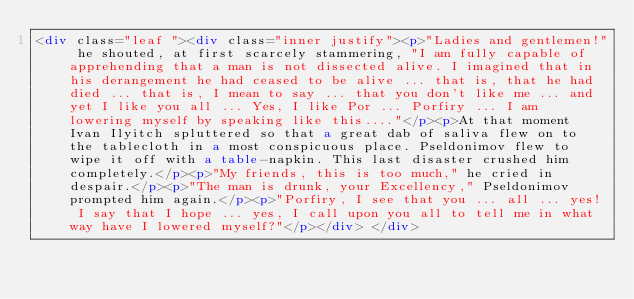Convert code to text. <code><loc_0><loc_0><loc_500><loc_500><_HTML_><div class="leaf "><div class="inner justify"><p>"Ladies and gentlemen!" he shouted, at first scarcely stammering, "I am fully capable of apprehending that a man is not dissected alive. I imagined that in his derangement he had ceased to be alive ... that is, that he had died ... that is, I mean to say ... that you don't like me ... and yet I like you all ... Yes, I like Por ... Porfiry ... I am lowering myself by speaking like this...."</p><p>At that moment Ivan Ilyitch spluttered so that a great dab of saliva flew on to the tablecloth in a most conspicuous place. Pseldonimov flew to wipe it off with a table-napkin. This last disaster crushed him completely.</p><p>"My friends, this is too much," he cried in despair.</p><p>"The man is drunk, your Excellency," Pseldonimov prompted him again.</p><p>"Porfiry, I see that you ... all ... yes! I say that I hope ... yes, I call upon you all to tell me in what way have I lowered myself?"</p></div> </div></code> 